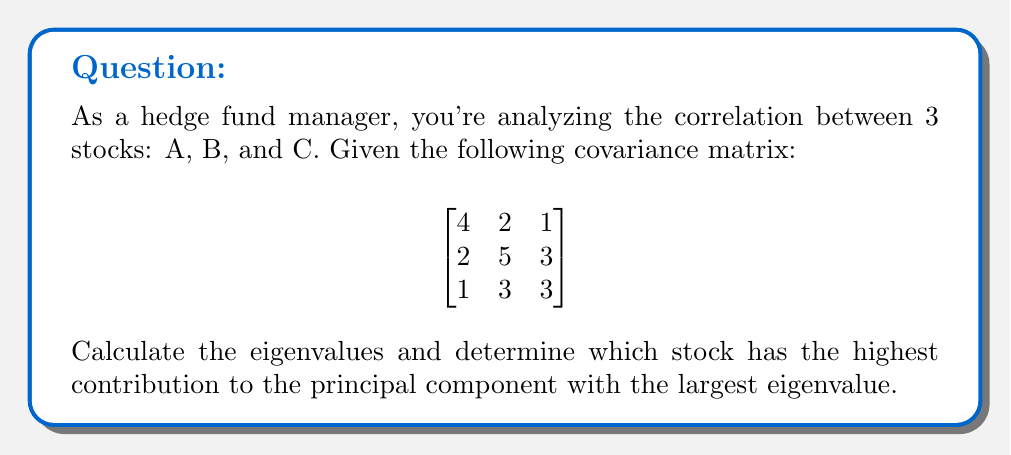Could you help me with this problem? 1) To find the eigenvalues, we need to solve the characteristic equation:
   $det(A - \lambda I) = 0$

2) Expanding the determinant:
   $$\begin{vmatrix}
   4-\lambda & 2 & 1 \\
   2 & 5-\lambda & 3 \\
   1 & 3 & 3-\lambda
   \end{vmatrix} = 0$$

3) This gives us the cubic equation:
   $-\lambda^3 + 12\lambda^2 - 31\lambda + 20 = 0$

4) Solving this equation (using a calculator or computer algebra system), we get:
   $\lambda_1 \approx 8.30$, $\lambda_2 \approx 2.54$, $\lambda_3 \approx 1.16$

5) The largest eigenvalue is $\lambda_1 \approx 8.30$

6) To find the corresponding eigenvector, we solve:
   $(A - 8.30I)\mathbf{v} = \mathbf{0}$

7) This gives us the eigenvector (normalized):
   $\mathbf{v}_1 \approx [0.4082, 0.7071, 0.5774]^T$

8) The components of this eigenvector represent the contributions of each stock to the principal component.

9) The largest component is 0.7071, corresponding to stock B.

Therefore, stock B has the highest contribution to the principal component with the largest eigenvalue.
Answer: Stock B 